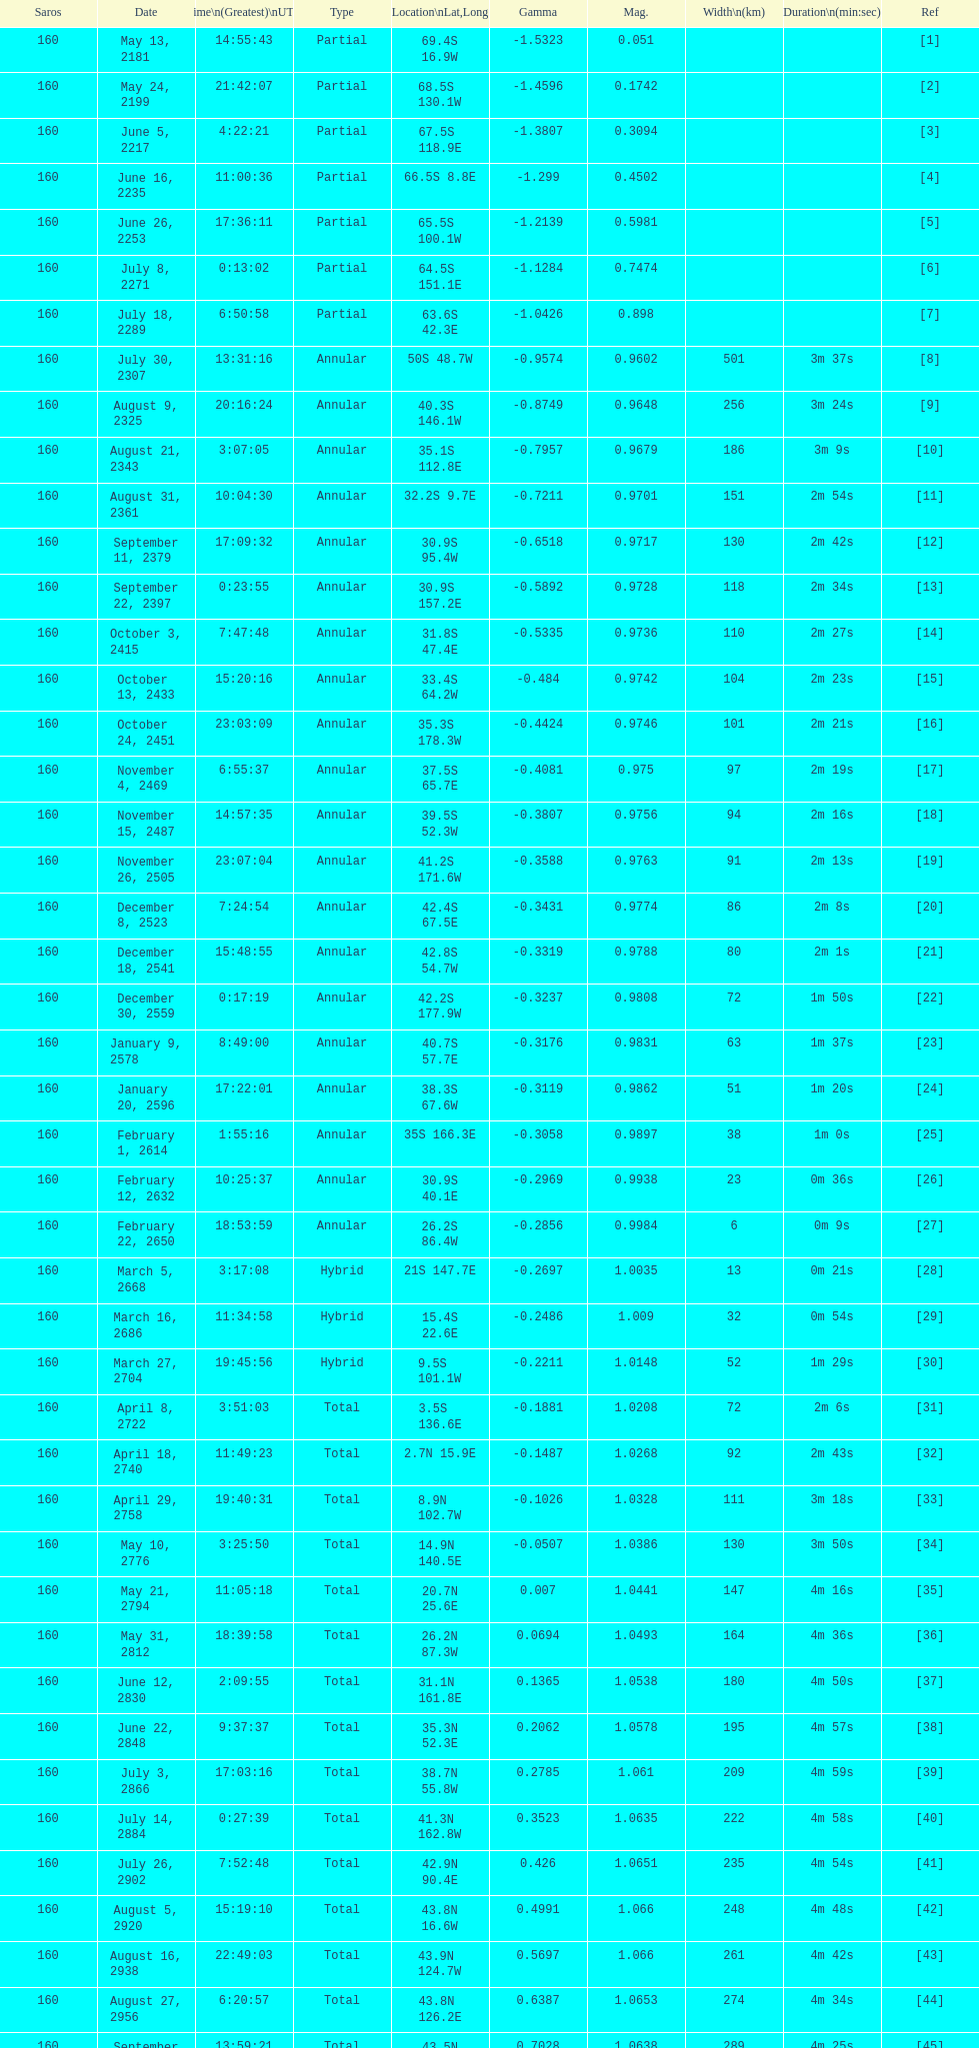Parse the table in full. {'header': ['Saros', 'Date', 'Time\\n(Greatest)\\nUTC', 'Type', 'Location\\nLat,Long', 'Gamma', 'Mag.', 'Width\\n(km)', 'Duration\\n(min:sec)', 'Ref'], 'rows': [['160', 'May 13, 2181', '14:55:43', 'Partial', '69.4S 16.9W', '-1.5323', '0.051', '', '', '[1]'], ['160', 'May 24, 2199', '21:42:07', 'Partial', '68.5S 130.1W', '-1.4596', '0.1742', '', '', '[2]'], ['160', 'June 5, 2217', '4:22:21', 'Partial', '67.5S 118.9E', '-1.3807', '0.3094', '', '', '[3]'], ['160', 'June 16, 2235', '11:00:36', 'Partial', '66.5S 8.8E', '-1.299', '0.4502', '', '', '[4]'], ['160', 'June 26, 2253', '17:36:11', 'Partial', '65.5S 100.1W', '-1.2139', '0.5981', '', '', '[5]'], ['160', 'July 8, 2271', '0:13:02', 'Partial', '64.5S 151.1E', '-1.1284', '0.7474', '', '', '[6]'], ['160', 'July 18, 2289', '6:50:58', 'Partial', '63.6S 42.3E', '-1.0426', '0.898', '', '', '[7]'], ['160', 'July 30, 2307', '13:31:16', 'Annular', '50S 48.7W', '-0.9574', '0.9602', '501', '3m 37s', '[8]'], ['160', 'August 9, 2325', '20:16:24', 'Annular', '40.3S 146.1W', '-0.8749', '0.9648', '256', '3m 24s', '[9]'], ['160', 'August 21, 2343', '3:07:05', 'Annular', '35.1S 112.8E', '-0.7957', '0.9679', '186', '3m 9s', '[10]'], ['160', 'August 31, 2361', '10:04:30', 'Annular', '32.2S 9.7E', '-0.7211', '0.9701', '151', '2m 54s', '[11]'], ['160', 'September 11, 2379', '17:09:32', 'Annular', '30.9S 95.4W', '-0.6518', '0.9717', '130', '2m 42s', '[12]'], ['160', 'September 22, 2397', '0:23:55', 'Annular', '30.9S 157.2E', '-0.5892', '0.9728', '118', '2m 34s', '[13]'], ['160', 'October 3, 2415', '7:47:48', 'Annular', '31.8S 47.4E', '-0.5335', '0.9736', '110', '2m 27s', '[14]'], ['160', 'October 13, 2433', '15:20:16', 'Annular', '33.4S 64.2W', '-0.484', '0.9742', '104', '2m 23s', '[15]'], ['160', 'October 24, 2451', '23:03:09', 'Annular', '35.3S 178.3W', '-0.4424', '0.9746', '101', '2m 21s', '[16]'], ['160', 'November 4, 2469', '6:55:37', 'Annular', '37.5S 65.7E', '-0.4081', '0.975', '97', '2m 19s', '[17]'], ['160', 'November 15, 2487', '14:57:35', 'Annular', '39.5S 52.3W', '-0.3807', '0.9756', '94', '2m 16s', '[18]'], ['160', 'November 26, 2505', '23:07:04', 'Annular', '41.2S 171.6W', '-0.3588', '0.9763', '91', '2m 13s', '[19]'], ['160', 'December 8, 2523', '7:24:54', 'Annular', '42.4S 67.5E', '-0.3431', '0.9774', '86', '2m 8s', '[20]'], ['160', 'December 18, 2541', '15:48:55', 'Annular', '42.8S 54.7W', '-0.3319', '0.9788', '80', '2m 1s', '[21]'], ['160', 'December 30, 2559', '0:17:19', 'Annular', '42.2S 177.9W', '-0.3237', '0.9808', '72', '1m 50s', '[22]'], ['160', 'January 9, 2578', '8:49:00', 'Annular', '40.7S 57.7E', '-0.3176', '0.9831', '63', '1m 37s', '[23]'], ['160', 'January 20, 2596', '17:22:01', 'Annular', '38.3S 67.6W', '-0.3119', '0.9862', '51', '1m 20s', '[24]'], ['160', 'February 1, 2614', '1:55:16', 'Annular', '35S 166.3E', '-0.3058', '0.9897', '38', '1m 0s', '[25]'], ['160', 'February 12, 2632', '10:25:37', 'Annular', '30.9S 40.1E', '-0.2969', '0.9938', '23', '0m 36s', '[26]'], ['160', 'February 22, 2650', '18:53:59', 'Annular', '26.2S 86.4W', '-0.2856', '0.9984', '6', '0m 9s', '[27]'], ['160', 'March 5, 2668', '3:17:08', 'Hybrid', '21S 147.7E', '-0.2697', '1.0035', '13', '0m 21s', '[28]'], ['160', 'March 16, 2686', '11:34:58', 'Hybrid', '15.4S 22.6E', '-0.2486', '1.009', '32', '0m 54s', '[29]'], ['160', 'March 27, 2704', '19:45:56', 'Hybrid', '9.5S 101.1W', '-0.2211', '1.0148', '52', '1m 29s', '[30]'], ['160', 'April 8, 2722', '3:51:03', 'Total', '3.5S 136.6E', '-0.1881', '1.0208', '72', '2m 6s', '[31]'], ['160', 'April 18, 2740', '11:49:23', 'Total', '2.7N 15.9E', '-0.1487', '1.0268', '92', '2m 43s', '[32]'], ['160', 'April 29, 2758', '19:40:31', 'Total', '8.9N 102.7W', '-0.1026', '1.0328', '111', '3m 18s', '[33]'], ['160', 'May 10, 2776', '3:25:50', 'Total', '14.9N 140.5E', '-0.0507', '1.0386', '130', '3m 50s', '[34]'], ['160', 'May 21, 2794', '11:05:18', 'Total', '20.7N 25.6E', '0.007', '1.0441', '147', '4m 16s', '[35]'], ['160', 'May 31, 2812', '18:39:58', 'Total', '26.2N 87.3W', '0.0694', '1.0493', '164', '4m 36s', '[36]'], ['160', 'June 12, 2830', '2:09:55', 'Total', '31.1N 161.8E', '0.1365', '1.0538', '180', '4m 50s', '[37]'], ['160', 'June 22, 2848', '9:37:37', 'Total', '35.3N 52.3E', '0.2062', '1.0578', '195', '4m 57s', '[38]'], ['160', 'July 3, 2866', '17:03:16', 'Total', '38.7N 55.8W', '0.2785', '1.061', '209', '4m 59s', '[39]'], ['160', 'July 14, 2884', '0:27:39', 'Total', '41.3N 162.8W', '0.3523', '1.0635', '222', '4m 58s', '[40]'], ['160', 'July 26, 2902', '7:52:48', 'Total', '42.9N 90.4E', '0.426', '1.0651', '235', '4m 54s', '[41]'], ['160', 'August 5, 2920', '15:19:10', 'Total', '43.8N 16.6W', '0.4991', '1.066', '248', '4m 48s', '[42]'], ['160', 'August 16, 2938', '22:49:03', 'Total', '43.9N 124.7W', '0.5697', '1.066', '261', '4m 42s', '[43]'], ['160', 'August 27, 2956', '6:20:57', 'Total', '43.8N 126.2E', '0.6387', '1.0653', '274', '4m 34s', '[44]'], ['160', 'September 7, 2974', '13:59:21', 'Total', '43.5N 14.9E', '0.7028', '1.0638', '289', '4m 25s', '[45]'], ['160', 'September 17, 2992', '21:42:08', 'Total', '43.5N 98.1W', '0.7636', '1.0617', '307', '4m 16s', '[46]']]} How long did the the saros on july 30, 2307 last for? 3m 37s. 